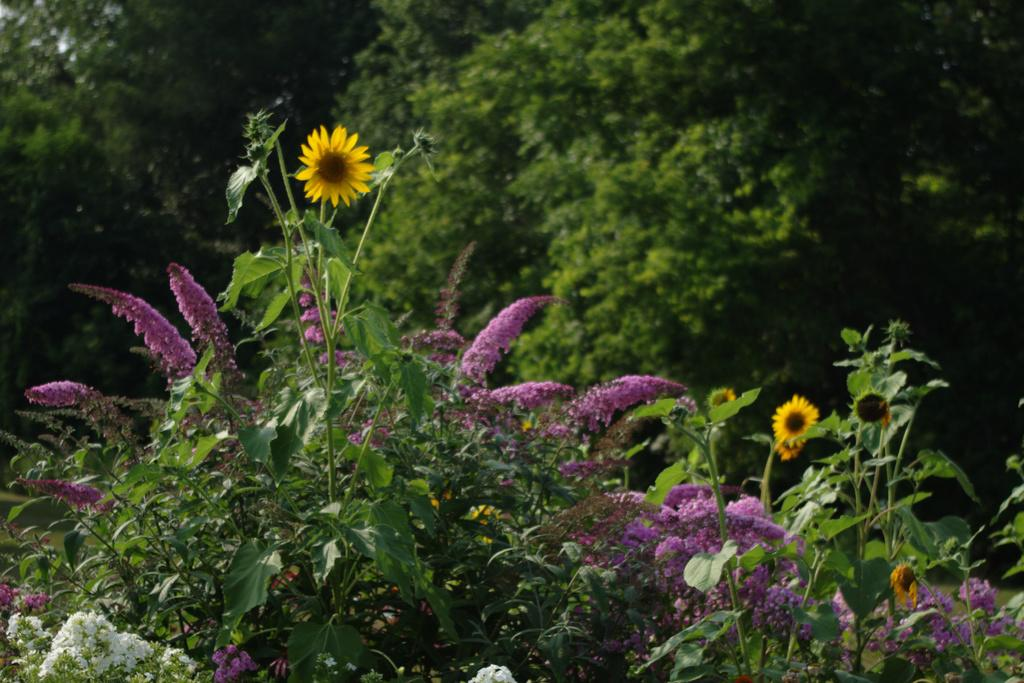What type of vegetation can be seen in the image? There are many trees and plants in the image. Do the plants have any specific features? Yes, the plants have flowers. What is the ground made of in the image? There is a grassy land in the image. How many hands can be seen holding the flowers in the image? There are no hands visible in the image; it only features trees, plants, and flowers. What type of fowl can be seen walking on the grassy land in the image? There are no fowl present in the image; it only features trees, plants, and flowers. 